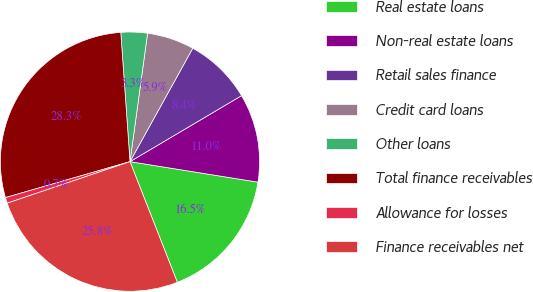<chart> <loc_0><loc_0><loc_500><loc_500><pie_chart><fcel>Real estate loans<fcel>Non-real estate loans<fcel>Retail sales finance<fcel>Credit card loans<fcel>Other loans<fcel>Total finance receivables<fcel>Allowance for losses<fcel>Finance receivables net<nl><fcel>16.52%<fcel>11.03%<fcel>8.45%<fcel>5.88%<fcel>3.3%<fcel>28.34%<fcel>0.72%<fcel>25.76%<nl></chart> 